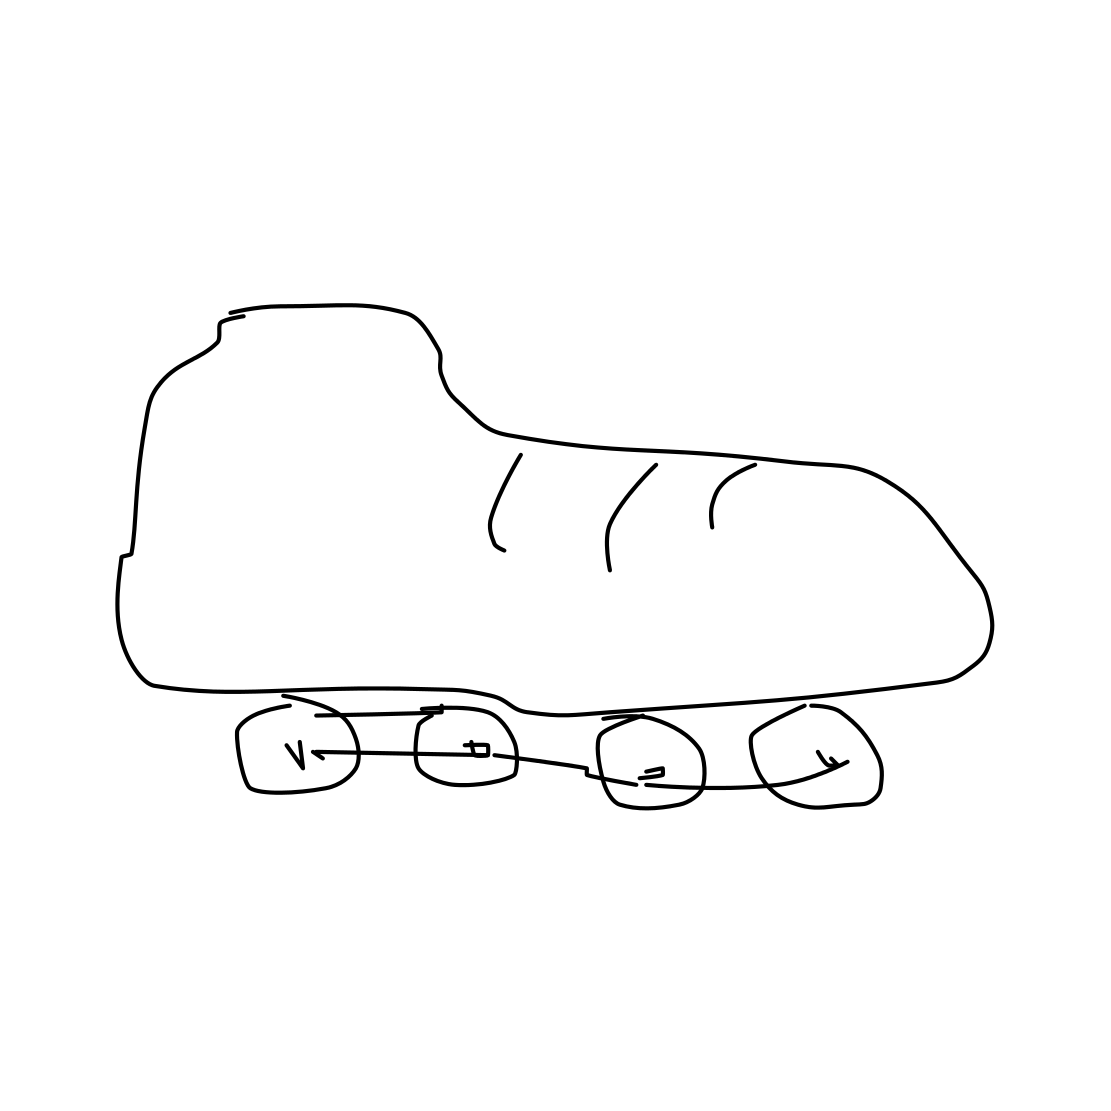Can you describe the style or type of the rollerblades shown in this sketch? The rollerblades in the sketch are of a minimalistic design, focusing mainly on the outline and the basic parts like the boot and wheels. The wheels are marked with numbers, possibly indicating a sequence or specific parts for educational or illustrative purposes. 